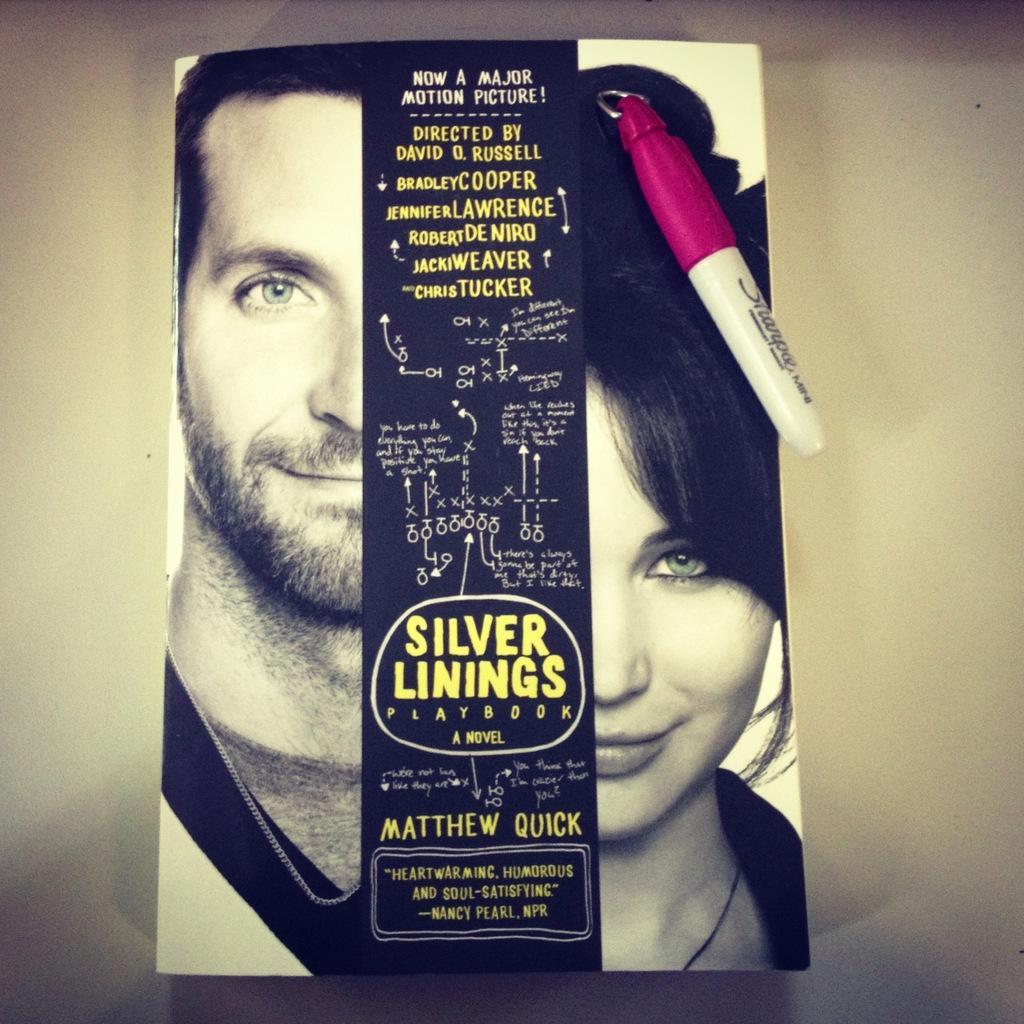How would you summarize this image in a sentence or two? In this picture I can observe cover page of a book. I can observe man and a woman on this cover page. In the background I can observe white color surface. 